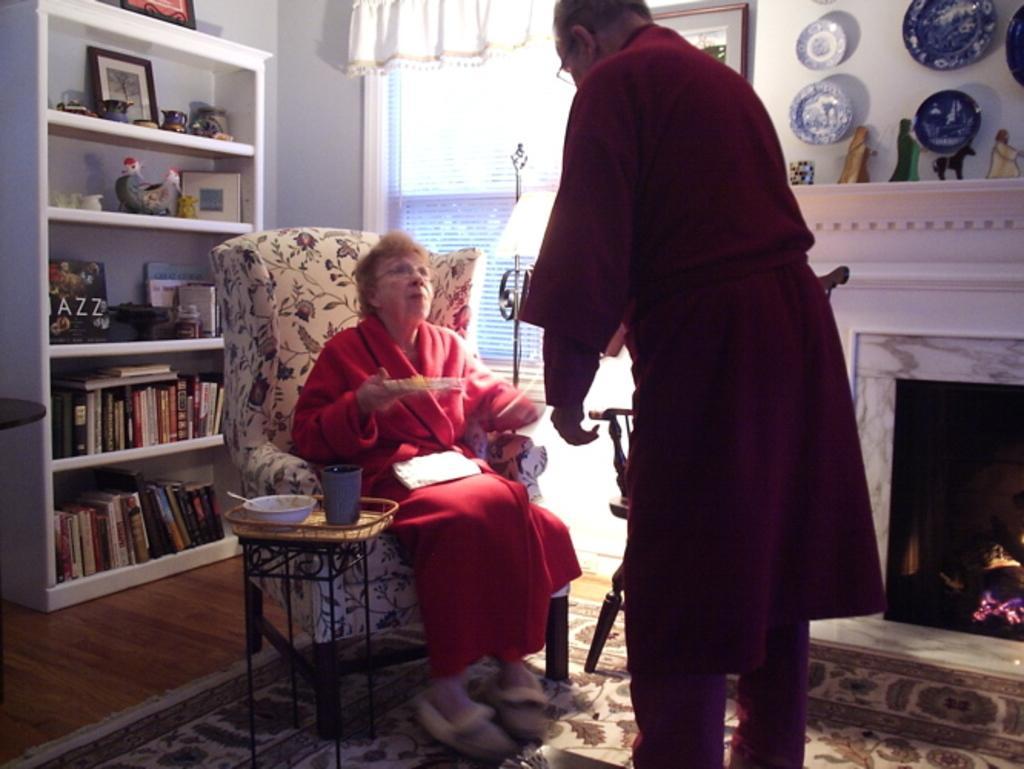Describe this image in one or two sentences. In this picture I can see a woman in the middle, beside her there is a man standing. On the left side there are books and other things on the shelves, on the right side I can see few things on the wall, there is a fireplace. In the background it looks like a window. 